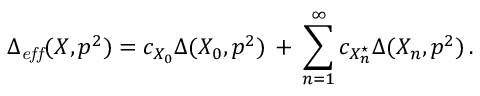<formula> <loc_0><loc_0><loc_500><loc_500>\Delta _ { e f f } ( X , p ^ { 2 } ) = c _ { X _ { 0 } } \Delta ( X _ { 0 } , p ^ { 2 } ) \, + \, \sum _ { n = 1 } ^ { \infty } c _ { X _ { n } ^ { ^ { * } } } \Delta ( X _ { n } , p ^ { 2 } ) \, .</formula> 